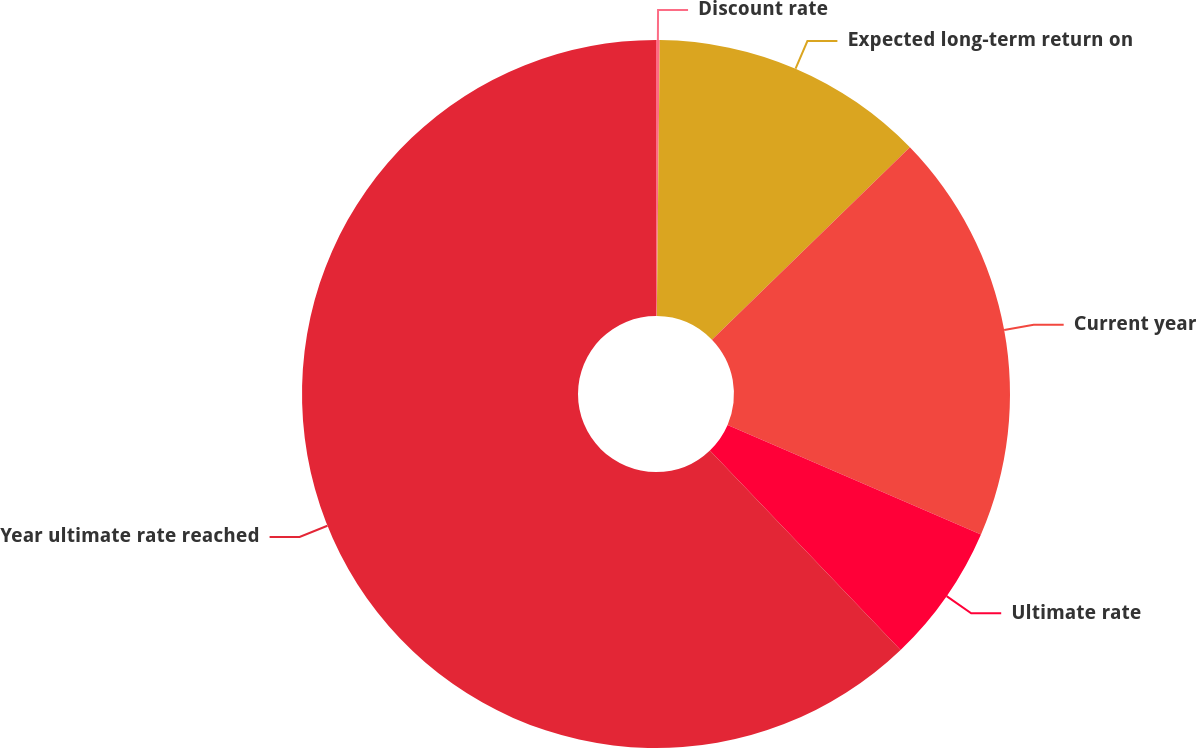Convert chart to OTSL. <chart><loc_0><loc_0><loc_500><loc_500><pie_chart><fcel>Discount rate<fcel>Expected long-term return on<fcel>Current year<fcel>Ultimate rate<fcel>Year ultimate rate reached<nl><fcel>0.17%<fcel>12.56%<fcel>18.76%<fcel>6.37%<fcel>62.14%<nl></chart> 